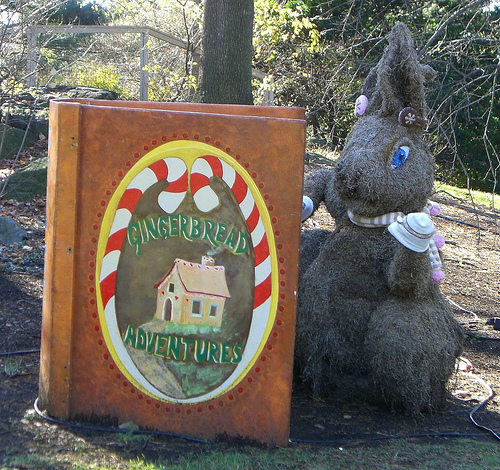<image>
Is there a book behind the rabbit? No. The book is not behind the rabbit. From this viewpoint, the book appears to be positioned elsewhere in the scene. 